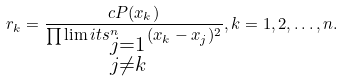<formula> <loc_0><loc_0><loc_500><loc_500>r _ { k } = \frac { c P ( x _ { k } ) } { \prod \lim i t s _ { \substack { j = 1 \\ j \neq k } } ^ { n } ( x _ { k } - x _ { j } ) ^ { 2 } } , k = 1 , 2 , \dots , n .</formula> 